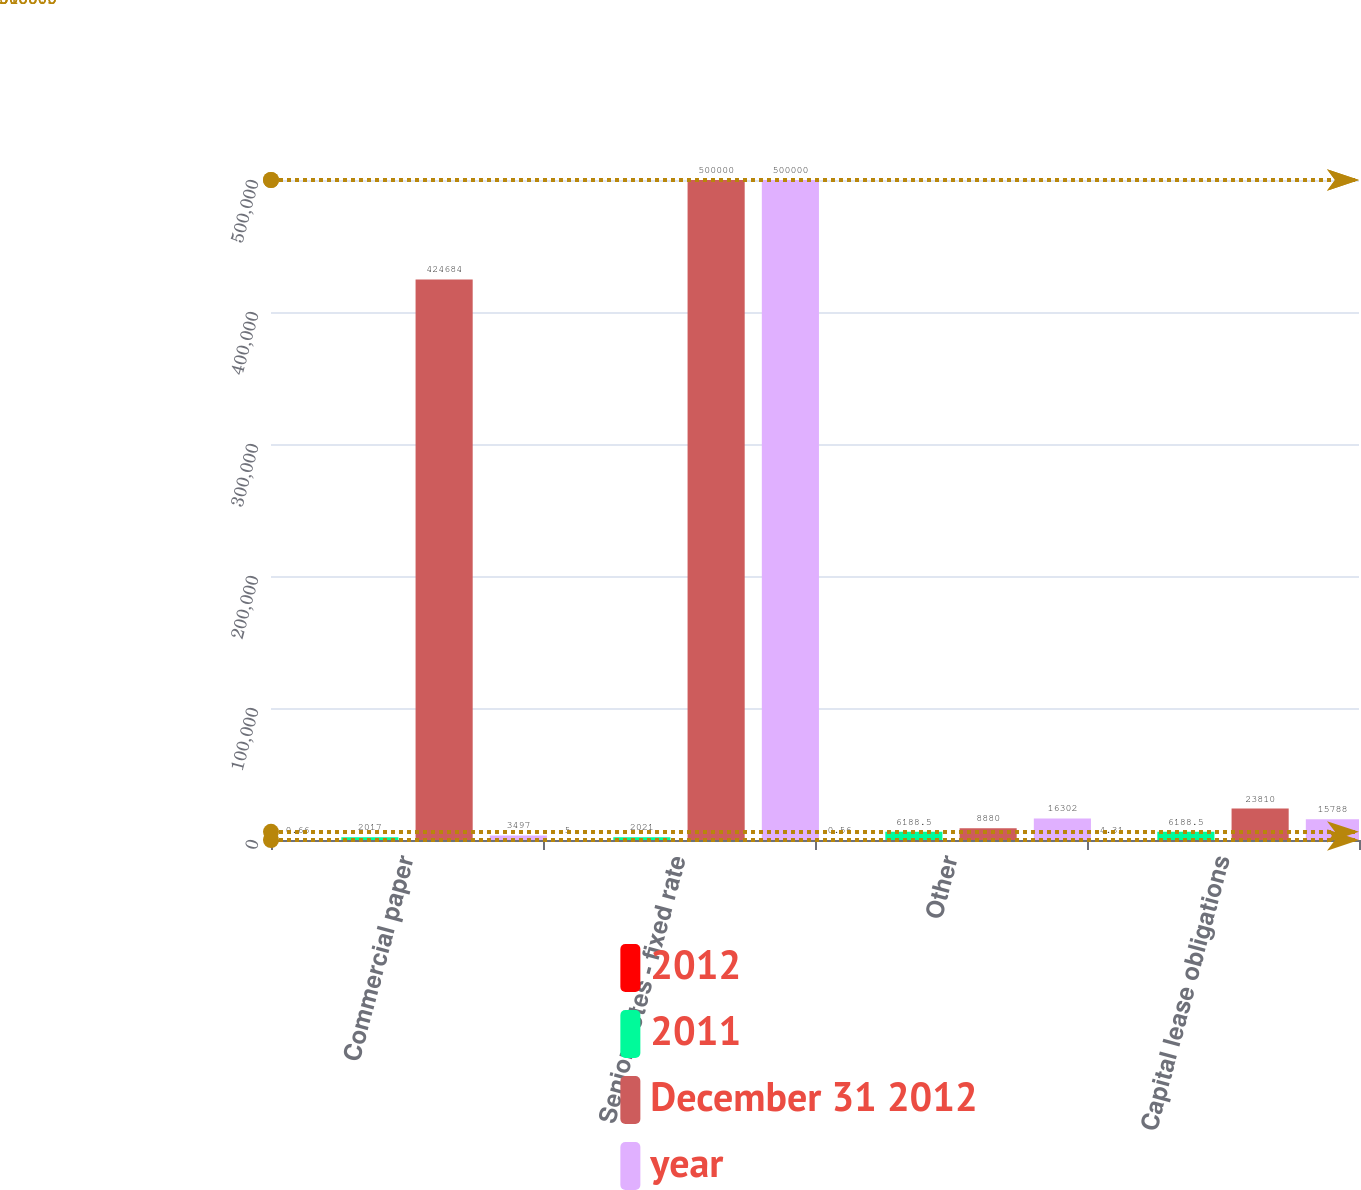<chart> <loc_0><loc_0><loc_500><loc_500><stacked_bar_chart><ecel><fcel>Commercial paper<fcel>Senior notes - fixed rate<fcel>Other<fcel>Capital lease obligations<nl><fcel>2012<fcel>0.66<fcel>5<fcel>0.56<fcel>4.31<nl><fcel>2011<fcel>2017<fcel>2021<fcel>6188.5<fcel>6188.5<nl><fcel>December 31 2012<fcel>424684<fcel>500000<fcel>8880<fcel>23810<nl><fcel>year<fcel>3497<fcel>500000<fcel>16302<fcel>15788<nl></chart> 